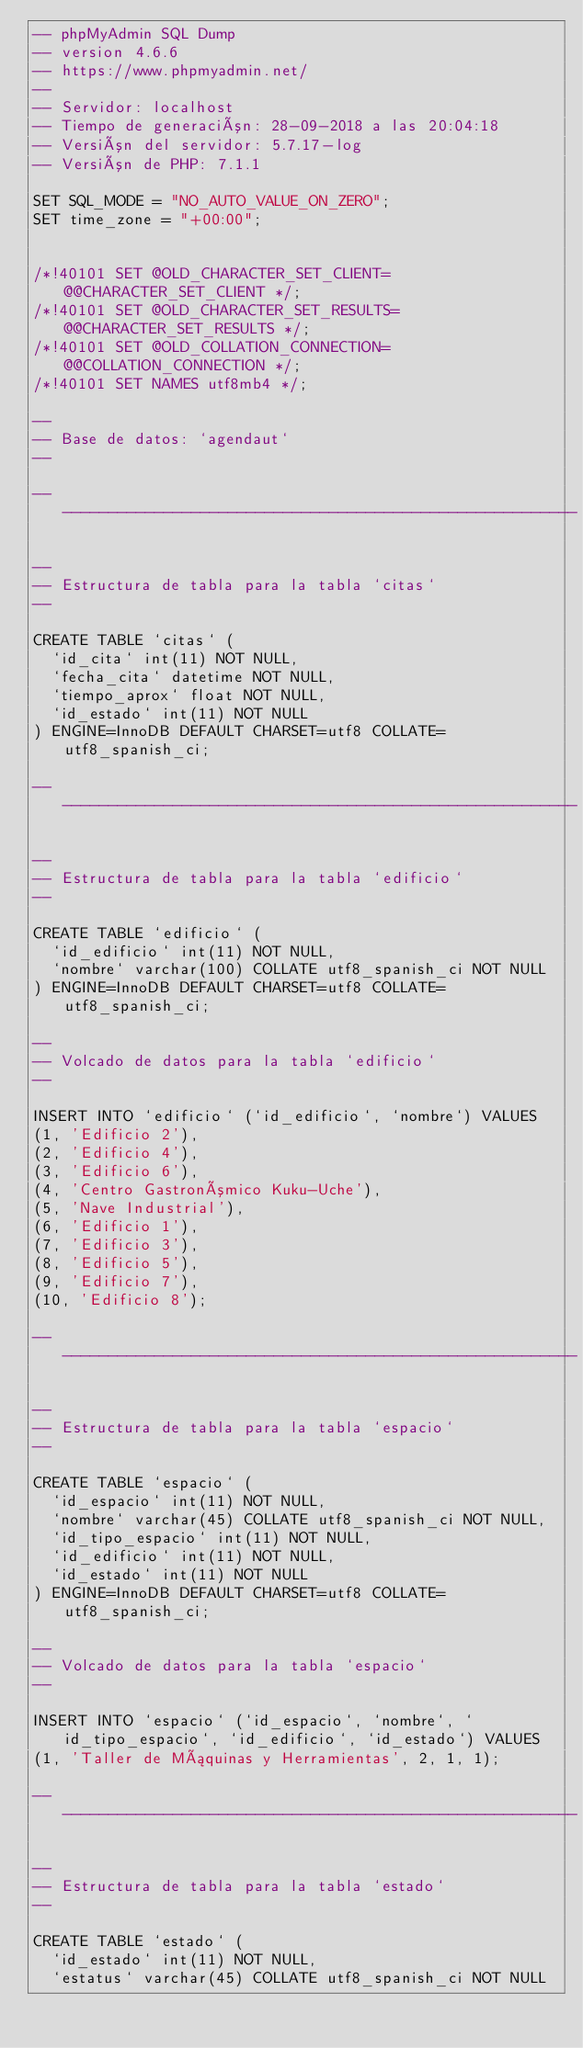<code> <loc_0><loc_0><loc_500><loc_500><_SQL_>-- phpMyAdmin SQL Dump
-- version 4.6.6
-- https://www.phpmyadmin.net/
--
-- Servidor: localhost
-- Tiempo de generación: 28-09-2018 a las 20:04:18
-- Versión del servidor: 5.7.17-log
-- Versión de PHP: 7.1.1

SET SQL_MODE = "NO_AUTO_VALUE_ON_ZERO";
SET time_zone = "+00:00";


/*!40101 SET @OLD_CHARACTER_SET_CLIENT=@@CHARACTER_SET_CLIENT */;
/*!40101 SET @OLD_CHARACTER_SET_RESULTS=@@CHARACTER_SET_RESULTS */;
/*!40101 SET @OLD_COLLATION_CONNECTION=@@COLLATION_CONNECTION */;
/*!40101 SET NAMES utf8mb4 */;

--
-- Base de datos: `agendaut`
--

-- --------------------------------------------------------

--
-- Estructura de tabla para la tabla `citas`
--

CREATE TABLE `citas` (
  `id_cita` int(11) NOT NULL,
  `fecha_cita` datetime NOT NULL,
  `tiempo_aprox` float NOT NULL,
  `id_estado` int(11) NOT NULL
) ENGINE=InnoDB DEFAULT CHARSET=utf8 COLLATE=utf8_spanish_ci;

-- --------------------------------------------------------

--
-- Estructura de tabla para la tabla `edificio`
--

CREATE TABLE `edificio` (
  `id_edificio` int(11) NOT NULL,
  `nombre` varchar(100) COLLATE utf8_spanish_ci NOT NULL
) ENGINE=InnoDB DEFAULT CHARSET=utf8 COLLATE=utf8_spanish_ci;

--
-- Volcado de datos para la tabla `edificio`
--

INSERT INTO `edificio` (`id_edificio`, `nombre`) VALUES
(1, 'Edificio 2'),
(2, 'Edificio 4'),
(3, 'Edificio 6'),
(4, 'Centro Gastronómico Kuku-Uche'),
(5, 'Nave Industrial'),
(6, 'Edificio 1'),
(7, 'Edificio 3'),
(8, 'Edificio 5'),
(9, 'Edificio 7'),
(10, 'Edificio 8');

-- --------------------------------------------------------

--
-- Estructura de tabla para la tabla `espacio`
--

CREATE TABLE `espacio` (
  `id_espacio` int(11) NOT NULL,
  `nombre` varchar(45) COLLATE utf8_spanish_ci NOT NULL,
  `id_tipo_espacio` int(11) NOT NULL,
  `id_edificio` int(11) NOT NULL,
  `id_estado` int(11) NOT NULL
) ENGINE=InnoDB DEFAULT CHARSET=utf8 COLLATE=utf8_spanish_ci;

--
-- Volcado de datos para la tabla `espacio`
--

INSERT INTO `espacio` (`id_espacio`, `nombre`, `id_tipo_espacio`, `id_edificio`, `id_estado`) VALUES
(1, 'Taller de Máquinas y Herramientas', 2, 1, 1);

-- --------------------------------------------------------

--
-- Estructura de tabla para la tabla `estado`
--

CREATE TABLE `estado` (
  `id_estado` int(11) NOT NULL,
  `estatus` varchar(45) COLLATE utf8_spanish_ci NOT NULL</code> 